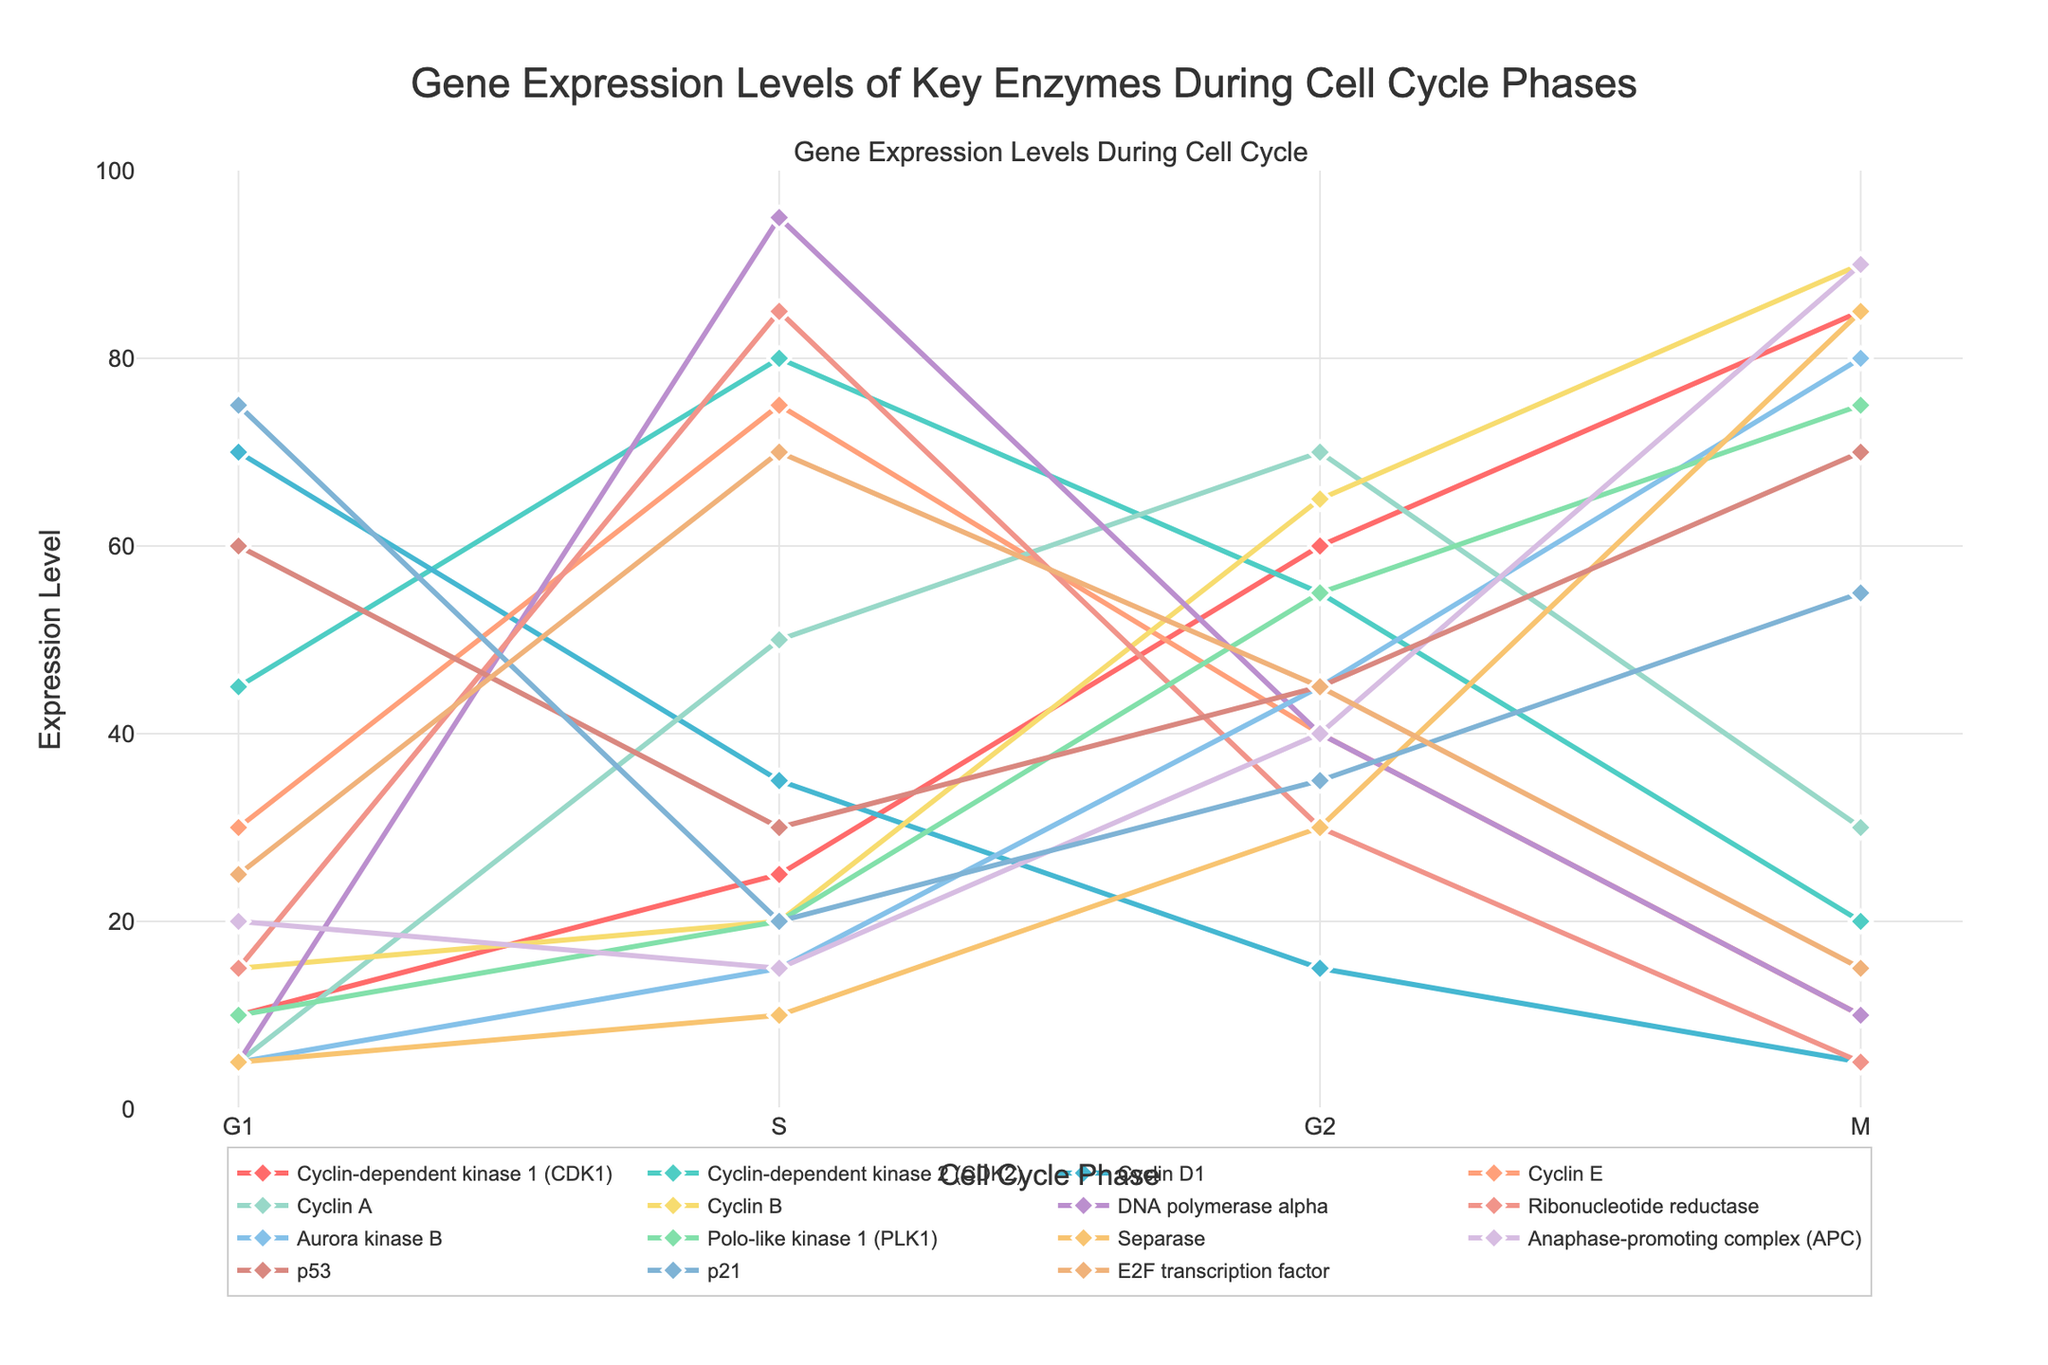Which enzyme has the highest expression level in the G1 phase? The enzyme with the highest expression level in the G1 phase can be found by identifying the maximum value in the G1 column. Cyclin D1 has the highest value of 70.
Answer: Cyclin D1 Which enzyme shows the greatest decrease in expression from S to M phase? To find the enzyme with the greatest decrease in expression, calculate the difference between S phase and M phase values for each enzyme and identify the maximum negative difference. DNA polymerase alpha decreases from 95 to 10, resulting in a decrease of 85.
Answer: DNA polymerase alpha What is the average expression level of Cyclin B across all phases? Sum the expression levels of Cyclin B across all phases (15 + 20 + 65 + 90) and divide by the number of phases (4). The sum is 190, and dividing by 4 results in an average of 47.5.
Answer: 47.5 Which enzyme has the highest expression level during the S phase and lowest during the M phase? Identifying the enzyme with the maximum value in the S phase and minimum value in the M phase involves reviewing the data for both phases. DNA polymerase alpha has the highest expression in the S phase (95) and one of the lowest in the M phase (10).
Answer: DNA polymerase alpha Which enzyme shows the highest increase in expression level from G2 to M phase? To find the enzyme with the highest increase, subtract the G2 phase value from the M phase value for each enzyme. Cyclin B increases from 65 to 90, resulting in an increase of 25.
Answer: Cyclin B Compare the expression levels of p53 between the G1 and M phases. Is the expression level higher in the G1 phase or M phase? To compare the expression levels, examine the values for p53 in the G1 (60) and M (70) phases. The expression level is higher in the M phase.
Answer: M phase Which enzyme's expression level steadily increases across the G1, S, G2, and M phases? An enzyme with a steadily increasing expression level will show a continuous rise in values across all phases. Cyclin B shows this trend, with values increasing from 15 to 20 to 65 to 90.
Answer: Cyclin B What is the expression level difference between Aurora kinase B in the G2 phase compared to the G1 phase? The difference is calculated by subtracting the G1 phase value (5) from the G2 phase value (45). The difference is 40.
Answer: 40 Which enzyme exhibits oscillatory expression patterns across the cell cycle phases, with high values alternating with low values? Identifying an enzyme with alternating high and low values across phases involves examining each enzyme's expression levels. Cyclin E shows this pattern with values of 30, 75, 40, and 10.
Answer: Cyclin E 